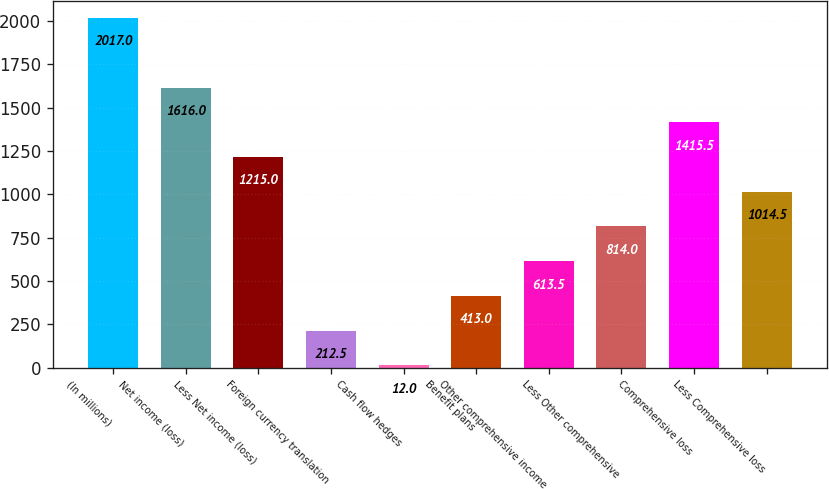<chart> <loc_0><loc_0><loc_500><loc_500><bar_chart><fcel>(In millions)<fcel>Net income (loss)<fcel>Less Net income (loss)<fcel>Foreign currency translation<fcel>Cash flow hedges<fcel>Benefit plans<fcel>Other comprehensive income<fcel>Less Other comprehensive<fcel>Comprehensive loss<fcel>Less Comprehensive loss<nl><fcel>2017<fcel>1616<fcel>1215<fcel>212.5<fcel>12<fcel>413<fcel>613.5<fcel>814<fcel>1415.5<fcel>1014.5<nl></chart> 